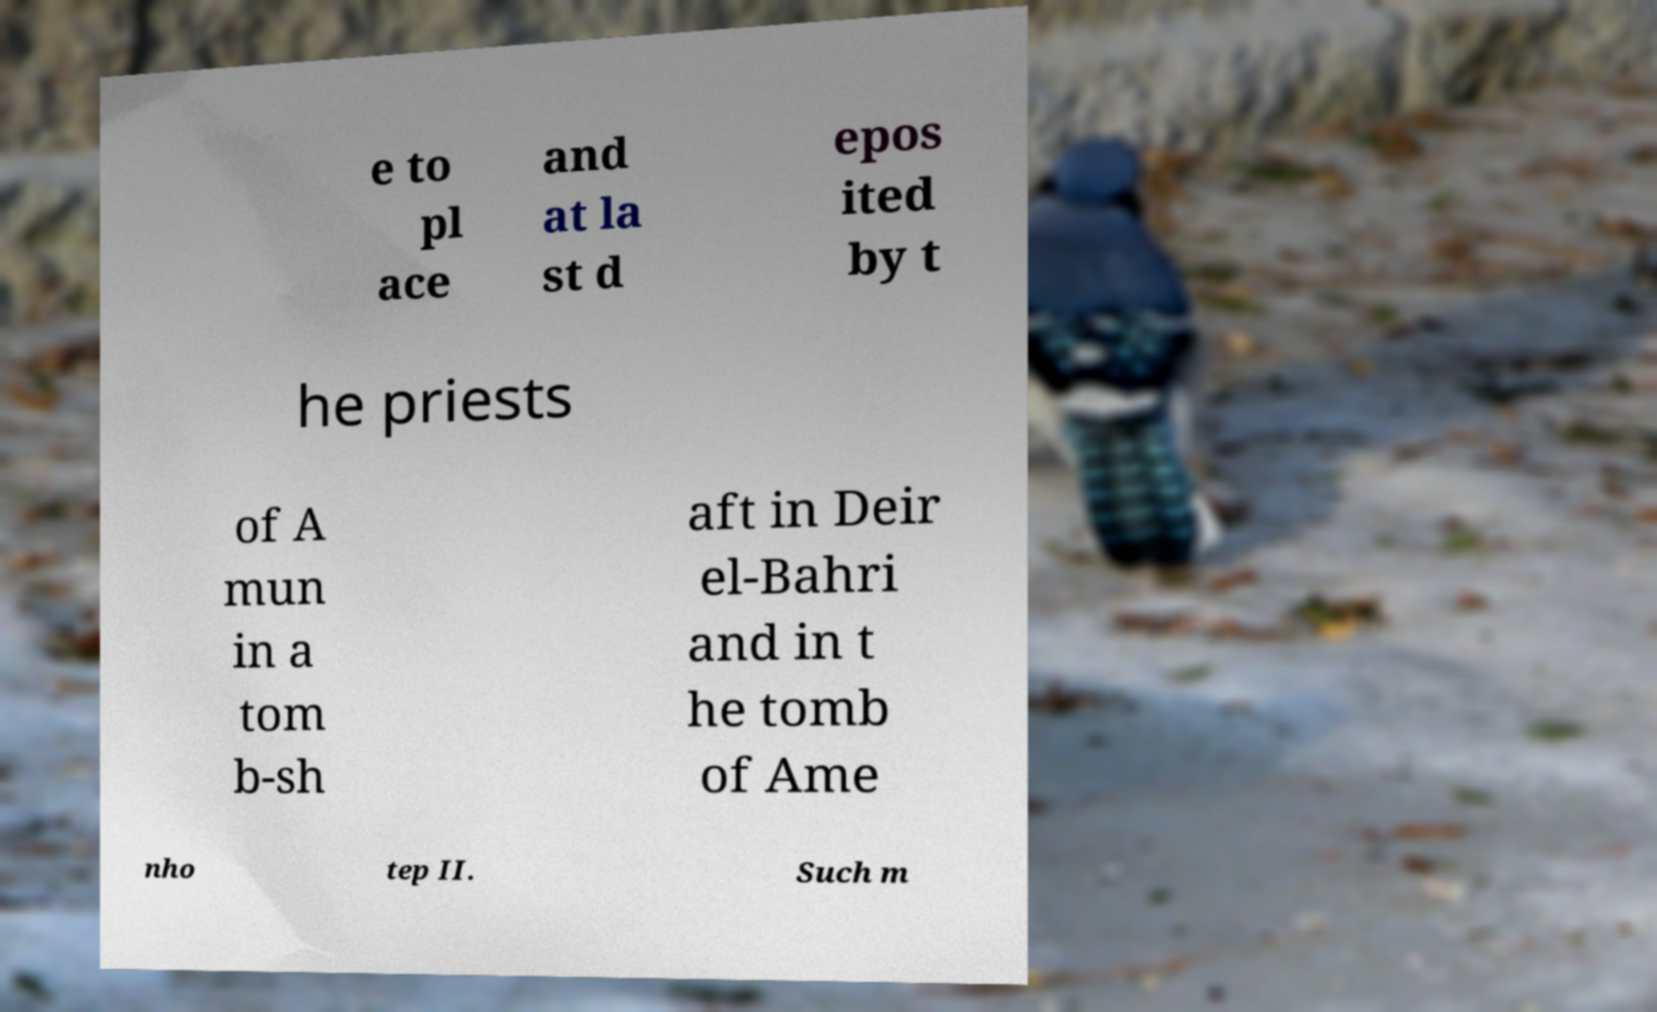Can you accurately transcribe the text from the provided image for me? e to pl ace and at la st d epos ited by t he priests of A mun in a tom b-sh aft in Deir el-Bahri and in t he tomb of Ame nho tep II. Such m 